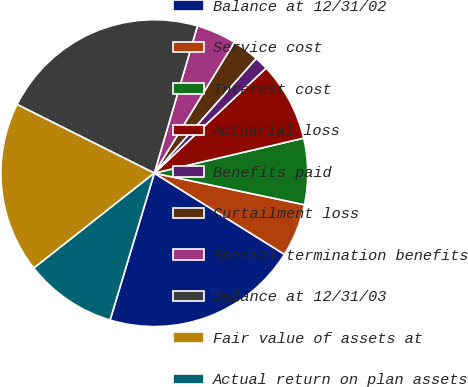Convert chart to OTSL. <chart><loc_0><loc_0><loc_500><loc_500><pie_chart><fcel>Balance at 12/31/02<fcel>Service cost<fcel>Interest cost<fcel>Actuarial loss<fcel>Benefits paid<fcel>Curtailment loss<fcel>Special termination benefits<fcel>Balance at 12/31/03<fcel>Fair value of assets at<fcel>Actual return on plan assets<nl><fcel>20.77%<fcel>5.58%<fcel>6.96%<fcel>8.34%<fcel>1.44%<fcel>2.82%<fcel>4.2%<fcel>22.15%<fcel>18.01%<fcel>9.72%<nl></chart> 